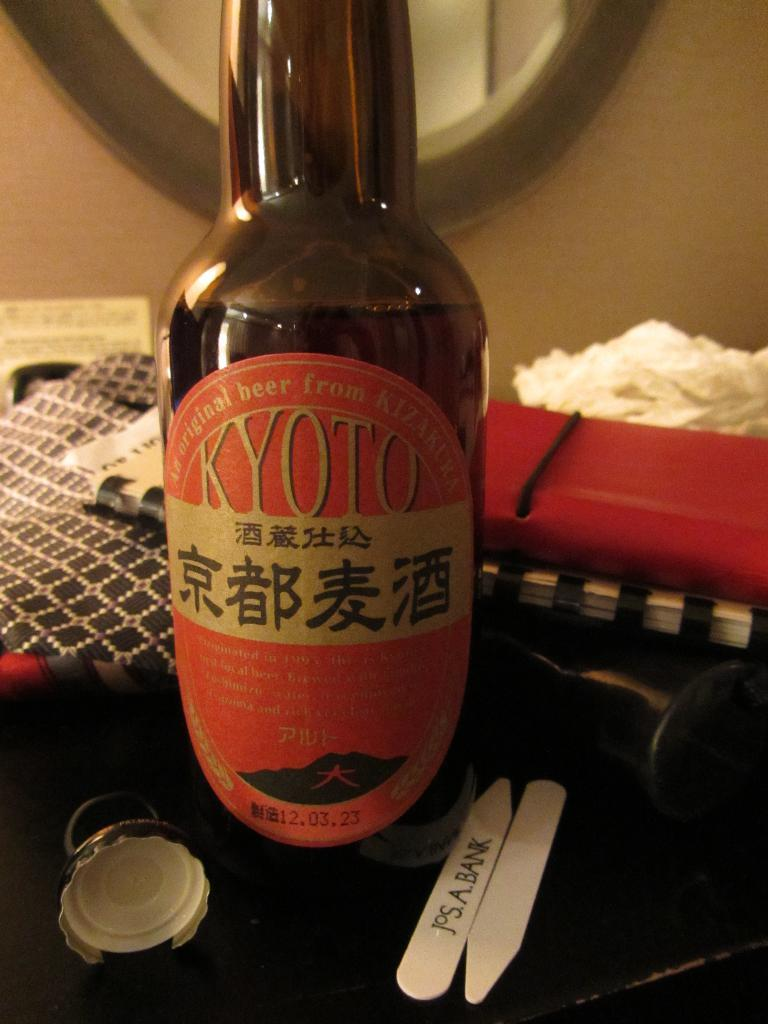<image>
Present a compact description of the photo's key features. A bottle of Kyoto sits on a desk in front of a miror 